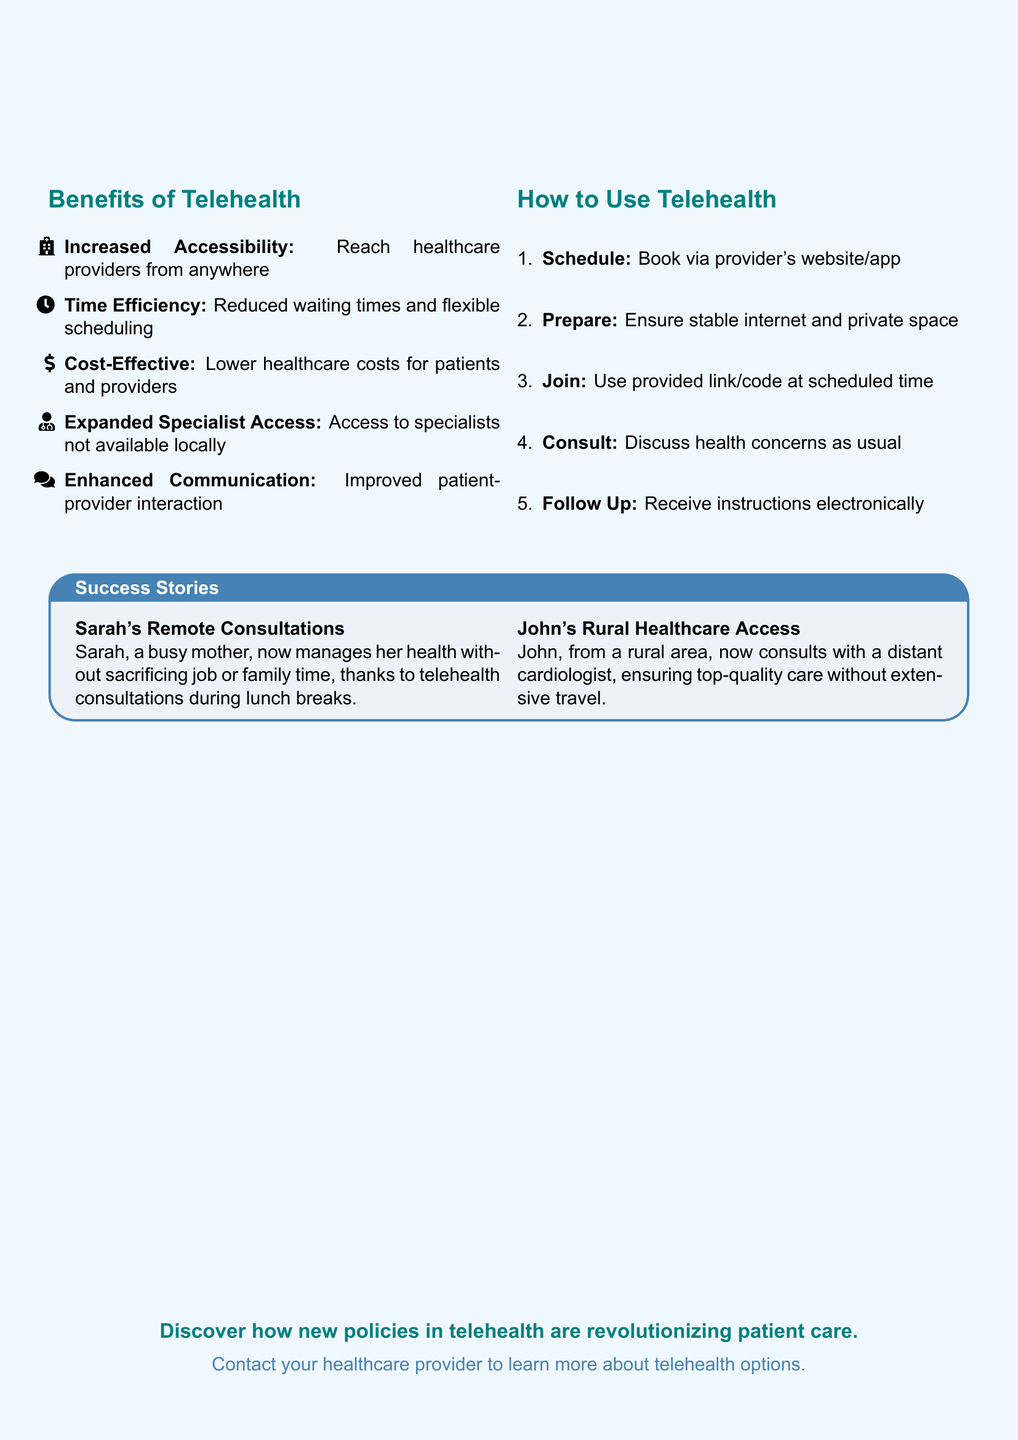What is the title of the advertisement? The title is prominently featured at the top of the document, indicating the main focus.
Answer: Telehealth Expansion What are two benefits of telehealth? The benefits listed are specific features of telehealth that improve patient care and accessibility.
Answer: Increased Accessibility, Time Efficiency What is the first step in using telehealth? The step-by-step instructions provide a clear process for engaging in telehealth services.
Answer: Schedule Who is Sarah in the success stories? Sarah is mentioned as a person benefiting from telehealth consultations, highlighting its positive impact.
Answer: A busy mother What type of healthcare access does John have? John's case illustrates the advantages of telehealth for individuals in specific geographical situations.
Answer: Rural Healthcare Access What color represents the secondary theme in the document? The document uses specific colors to enhance visual understanding and readability.
Answer: Secondary (RGB 70,130,180) What is one method of communication emphasized in telehealth? The benefits section highlights various aspects of patient-provider interaction that are enhanced through telehealth.
Answer: Enhanced Communication What follow-up method is used after a telehealth consultation? The instructions indicate how patients will receive guidance after their session.
Answer: Instructions electronically 